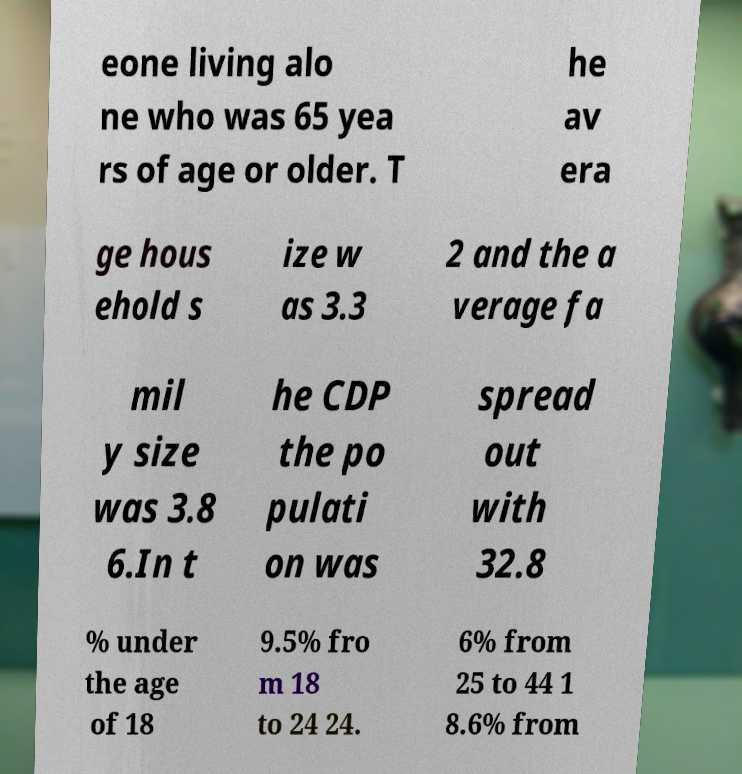Could you extract and type out the text from this image? eone living alo ne who was 65 yea rs of age or older. T he av era ge hous ehold s ize w as 3.3 2 and the a verage fa mil y size was 3.8 6.In t he CDP the po pulati on was spread out with 32.8 % under the age of 18 9.5% fro m 18 to 24 24. 6% from 25 to 44 1 8.6% from 